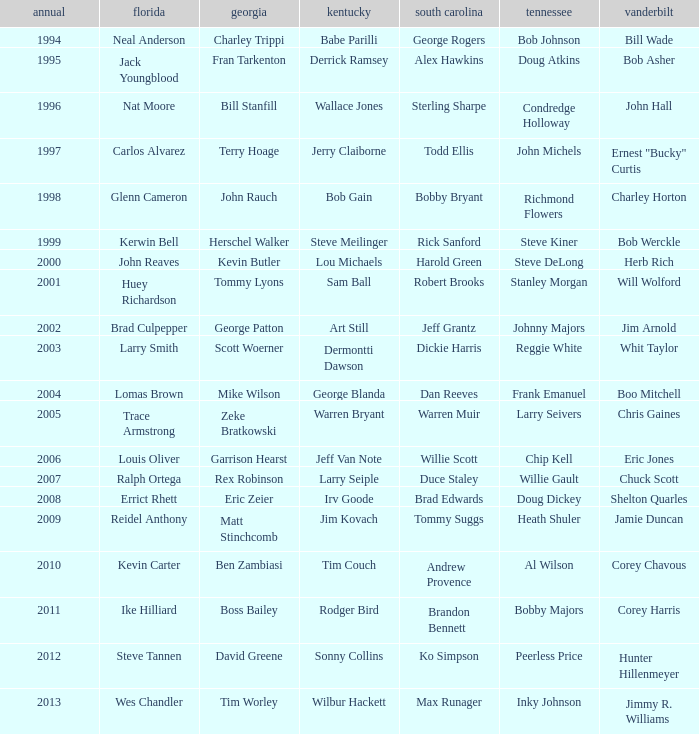What is the Tennessee that Georgia of kevin butler is in? Steve DeLong. 